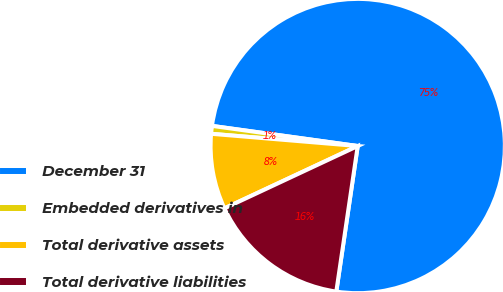<chart> <loc_0><loc_0><loc_500><loc_500><pie_chart><fcel>December 31<fcel>Embedded derivatives in<fcel>Total derivative assets<fcel>Total derivative liabilities<nl><fcel>75.14%<fcel>0.86%<fcel>8.29%<fcel>15.71%<nl></chart> 